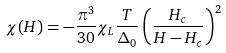Convert formula to latex. <formula><loc_0><loc_0><loc_500><loc_500>\chi ( H ) = - \frac { \pi ^ { 3 } } { 3 0 } \chi _ { L } \frac { T } { \Delta _ { 0 } } \left ( \frac { H _ { c } } { H - H _ { c } } \right ) ^ { 2 }</formula> 